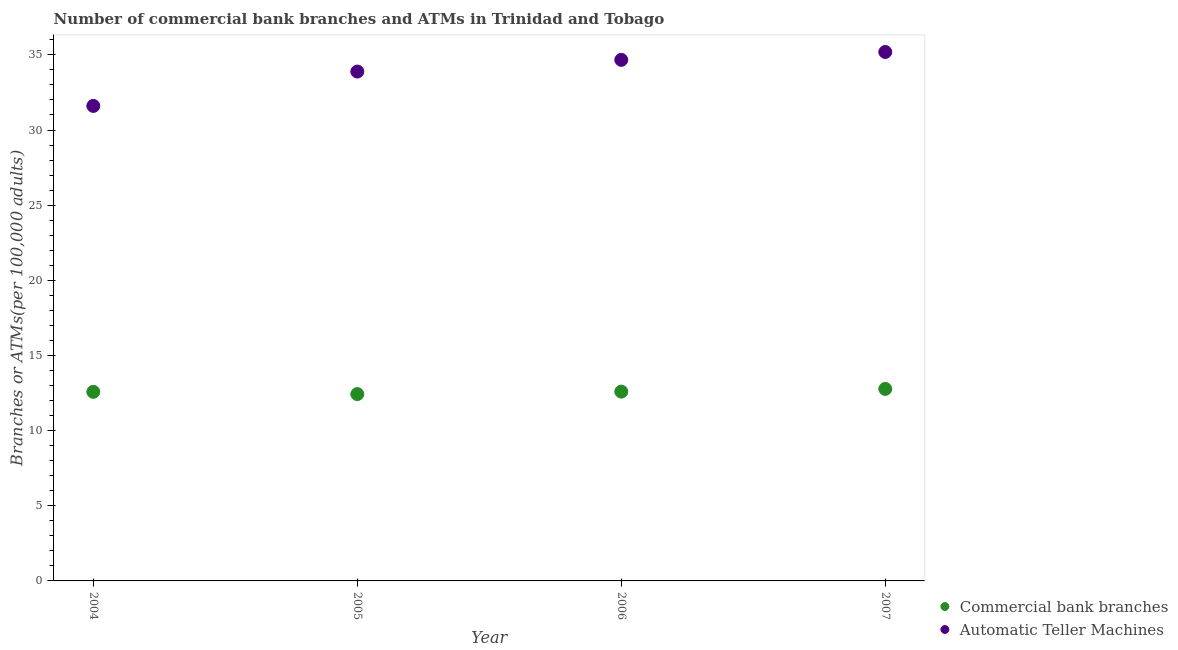Is the number of dotlines equal to the number of legend labels?
Your answer should be compact. Yes. What is the number of atms in 2004?
Give a very brief answer. 31.6. Across all years, what is the maximum number of commercal bank branches?
Your answer should be compact. 12.77. Across all years, what is the minimum number of atms?
Provide a short and direct response. 31.6. What is the total number of commercal bank branches in the graph?
Provide a succinct answer. 50.38. What is the difference between the number of atms in 2005 and that in 2006?
Your response must be concise. -0.78. What is the difference between the number of atms in 2007 and the number of commercal bank branches in 2004?
Your answer should be compact. 22.61. What is the average number of commercal bank branches per year?
Your answer should be compact. 12.6. In the year 2006, what is the difference between the number of commercal bank branches and number of atms?
Make the answer very short. -22.07. What is the ratio of the number of atms in 2005 to that in 2007?
Provide a succinct answer. 0.96. Is the number of atms in 2005 less than that in 2006?
Offer a very short reply. Yes. Is the difference between the number of commercal bank branches in 2004 and 2006 greater than the difference between the number of atms in 2004 and 2006?
Ensure brevity in your answer.  Yes. What is the difference between the highest and the second highest number of atms?
Provide a short and direct response. 0.52. What is the difference between the highest and the lowest number of atms?
Keep it short and to the point. 3.59. In how many years, is the number of commercal bank branches greater than the average number of commercal bank branches taken over all years?
Provide a short and direct response. 2. Is the number of commercal bank branches strictly greater than the number of atms over the years?
Provide a succinct answer. No. What is the difference between two consecutive major ticks on the Y-axis?
Offer a terse response. 5. Are the values on the major ticks of Y-axis written in scientific E-notation?
Make the answer very short. No. Where does the legend appear in the graph?
Your response must be concise. Bottom right. What is the title of the graph?
Your answer should be very brief. Number of commercial bank branches and ATMs in Trinidad and Tobago. What is the label or title of the X-axis?
Make the answer very short. Year. What is the label or title of the Y-axis?
Offer a terse response. Branches or ATMs(per 100,0 adults). What is the Branches or ATMs(per 100,000 adults) in Commercial bank branches in 2004?
Your answer should be very brief. 12.58. What is the Branches or ATMs(per 100,000 adults) of Automatic Teller Machines in 2004?
Make the answer very short. 31.6. What is the Branches or ATMs(per 100,000 adults) of Commercial bank branches in 2005?
Offer a terse response. 12.43. What is the Branches or ATMs(per 100,000 adults) of Automatic Teller Machines in 2005?
Offer a terse response. 33.89. What is the Branches or ATMs(per 100,000 adults) in Commercial bank branches in 2006?
Make the answer very short. 12.6. What is the Branches or ATMs(per 100,000 adults) of Automatic Teller Machines in 2006?
Make the answer very short. 34.67. What is the Branches or ATMs(per 100,000 adults) in Commercial bank branches in 2007?
Your answer should be very brief. 12.77. What is the Branches or ATMs(per 100,000 adults) in Automatic Teller Machines in 2007?
Make the answer very short. 35.19. Across all years, what is the maximum Branches or ATMs(per 100,000 adults) of Commercial bank branches?
Provide a short and direct response. 12.77. Across all years, what is the maximum Branches or ATMs(per 100,000 adults) in Automatic Teller Machines?
Your answer should be very brief. 35.19. Across all years, what is the minimum Branches or ATMs(per 100,000 adults) in Commercial bank branches?
Keep it short and to the point. 12.43. Across all years, what is the minimum Branches or ATMs(per 100,000 adults) of Automatic Teller Machines?
Give a very brief answer. 31.6. What is the total Branches or ATMs(per 100,000 adults) in Commercial bank branches in the graph?
Provide a short and direct response. 50.38. What is the total Branches or ATMs(per 100,000 adults) in Automatic Teller Machines in the graph?
Give a very brief answer. 135.35. What is the difference between the Branches or ATMs(per 100,000 adults) of Commercial bank branches in 2004 and that in 2005?
Your answer should be very brief. 0.15. What is the difference between the Branches or ATMs(per 100,000 adults) in Automatic Teller Machines in 2004 and that in 2005?
Offer a very short reply. -2.29. What is the difference between the Branches or ATMs(per 100,000 adults) in Commercial bank branches in 2004 and that in 2006?
Offer a terse response. -0.02. What is the difference between the Branches or ATMs(per 100,000 adults) of Automatic Teller Machines in 2004 and that in 2006?
Make the answer very short. -3.06. What is the difference between the Branches or ATMs(per 100,000 adults) in Commercial bank branches in 2004 and that in 2007?
Provide a short and direct response. -0.2. What is the difference between the Branches or ATMs(per 100,000 adults) of Automatic Teller Machines in 2004 and that in 2007?
Provide a short and direct response. -3.59. What is the difference between the Branches or ATMs(per 100,000 adults) of Commercial bank branches in 2005 and that in 2006?
Your answer should be compact. -0.16. What is the difference between the Branches or ATMs(per 100,000 adults) of Automatic Teller Machines in 2005 and that in 2006?
Provide a succinct answer. -0.78. What is the difference between the Branches or ATMs(per 100,000 adults) in Commercial bank branches in 2005 and that in 2007?
Your answer should be compact. -0.34. What is the difference between the Branches or ATMs(per 100,000 adults) in Automatic Teller Machines in 2005 and that in 2007?
Your answer should be compact. -1.3. What is the difference between the Branches or ATMs(per 100,000 adults) of Commercial bank branches in 2006 and that in 2007?
Ensure brevity in your answer.  -0.18. What is the difference between the Branches or ATMs(per 100,000 adults) of Automatic Teller Machines in 2006 and that in 2007?
Give a very brief answer. -0.52. What is the difference between the Branches or ATMs(per 100,000 adults) in Commercial bank branches in 2004 and the Branches or ATMs(per 100,000 adults) in Automatic Teller Machines in 2005?
Ensure brevity in your answer.  -21.31. What is the difference between the Branches or ATMs(per 100,000 adults) in Commercial bank branches in 2004 and the Branches or ATMs(per 100,000 adults) in Automatic Teller Machines in 2006?
Your answer should be very brief. -22.09. What is the difference between the Branches or ATMs(per 100,000 adults) of Commercial bank branches in 2004 and the Branches or ATMs(per 100,000 adults) of Automatic Teller Machines in 2007?
Offer a very short reply. -22.61. What is the difference between the Branches or ATMs(per 100,000 adults) in Commercial bank branches in 2005 and the Branches or ATMs(per 100,000 adults) in Automatic Teller Machines in 2006?
Keep it short and to the point. -22.24. What is the difference between the Branches or ATMs(per 100,000 adults) in Commercial bank branches in 2005 and the Branches or ATMs(per 100,000 adults) in Automatic Teller Machines in 2007?
Your response must be concise. -22.76. What is the difference between the Branches or ATMs(per 100,000 adults) of Commercial bank branches in 2006 and the Branches or ATMs(per 100,000 adults) of Automatic Teller Machines in 2007?
Offer a very short reply. -22.6. What is the average Branches or ATMs(per 100,000 adults) of Commercial bank branches per year?
Your response must be concise. 12.6. What is the average Branches or ATMs(per 100,000 adults) in Automatic Teller Machines per year?
Provide a short and direct response. 33.84. In the year 2004, what is the difference between the Branches or ATMs(per 100,000 adults) in Commercial bank branches and Branches or ATMs(per 100,000 adults) in Automatic Teller Machines?
Offer a terse response. -19.02. In the year 2005, what is the difference between the Branches or ATMs(per 100,000 adults) of Commercial bank branches and Branches or ATMs(per 100,000 adults) of Automatic Teller Machines?
Offer a terse response. -21.46. In the year 2006, what is the difference between the Branches or ATMs(per 100,000 adults) of Commercial bank branches and Branches or ATMs(per 100,000 adults) of Automatic Teller Machines?
Your response must be concise. -22.07. In the year 2007, what is the difference between the Branches or ATMs(per 100,000 adults) of Commercial bank branches and Branches or ATMs(per 100,000 adults) of Automatic Teller Machines?
Provide a succinct answer. -22.42. What is the ratio of the Branches or ATMs(per 100,000 adults) of Commercial bank branches in 2004 to that in 2005?
Provide a succinct answer. 1.01. What is the ratio of the Branches or ATMs(per 100,000 adults) of Automatic Teller Machines in 2004 to that in 2005?
Ensure brevity in your answer.  0.93. What is the ratio of the Branches or ATMs(per 100,000 adults) of Commercial bank branches in 2004 to that in 2006?
Ensure brevity in your answer.  1. What is the ratio of the Branches or ATMs(per 100,000 adults) of Automatic Teller Machines in 2004 to that in 2006?
Offer a very short reply. 0.91. What is the ratio of the Branches or ATMs(per 100,000 adults) of Commercial bank branches in 2004 to that in 2007?
Provide a short and direct response. 0.98. What is the ratio of the Branches or ATMs(per 100,000 adults) in Automatic Teller Machines in 2004 to that in 2007?
Make the answer very short. 0.9. What is the ratio of the Branches or ATMs(per 100,000 adults) in Commercial bank branches in 2005 to that in 2006?
Your response must be concise. 0.99. What is the ratio of the Branches or ATMs(per 100,000 adults) in Automatic Teller Machines in 2005 to that in 2006?
Your answer should be very brief. 0.98. What is the ratio of the Branches or ATMs(per 100,000 adults) in Commercial bank branches in 2005 to that in 2007?
Offer a very short reply. 0.97. What is the ratio of the Branches or ATMs(per 100,000 adults) of Automatic Teller Machines in 2006 to that in 2007?
Provide a short and direct response. 0.99. What is the difference between the highest and the second highest Branches or ATMs(per 100,000 adults) in Commercial bank branches?
Your answer should be very brief. 0.18. What is the difference between the highest and the second highest Branches or ATMs(per 100,000 adults) in Automatic Teller Machines?
Your answer should be very brief. 0.52. What is the difference between the highest and the lowest Branches or ATMs(per 100,000 adults) in Commercial bank branches?
Give a very brief answer. 0.34. What is the difference between the highest and the lowest Branches or ATMs(per 100,000 adults) of Automatic Teller Machines?
Keep it short and to the point. 3.59. 